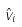<formula> <loc_0><loc_0><loc_500><loc_500>\hat { v } _ { i }</formula> 